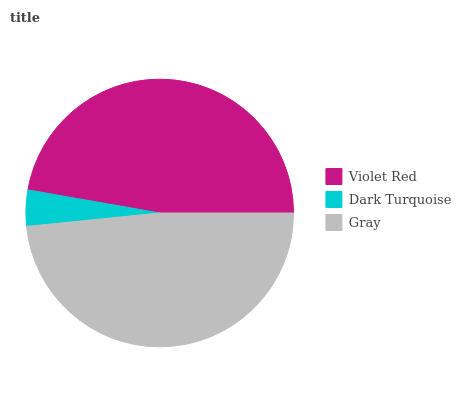Is Dark Turquoise the minimum?
Answer yes or no. Yes. Is Gray the maximum?
Answer yes or no. Yes. Is Gray the minimum?
Answer yes or no. No. Is Dark Turquoise the maximum?
Answer yes or no. No. Is Gray greater than Dark Turquoise?
Answer yes or no. Yes. Is Dark Turquoise less than Gray?
Answer yes or no. Yes. Is Dark Turquoise greater than Gray?
Answer yes or no. No. Is Gray less than Dark Turquoise?
Answer yes or no. No. Is Violet Red the high median?
Answer yes or no. Yes. Is Violet Red the low median?
Answer yes or no. Yes. Is Dark Turquoise the high median?
Answer yes or no. No. Is Gray the low median?
Answer yes or no. No. 